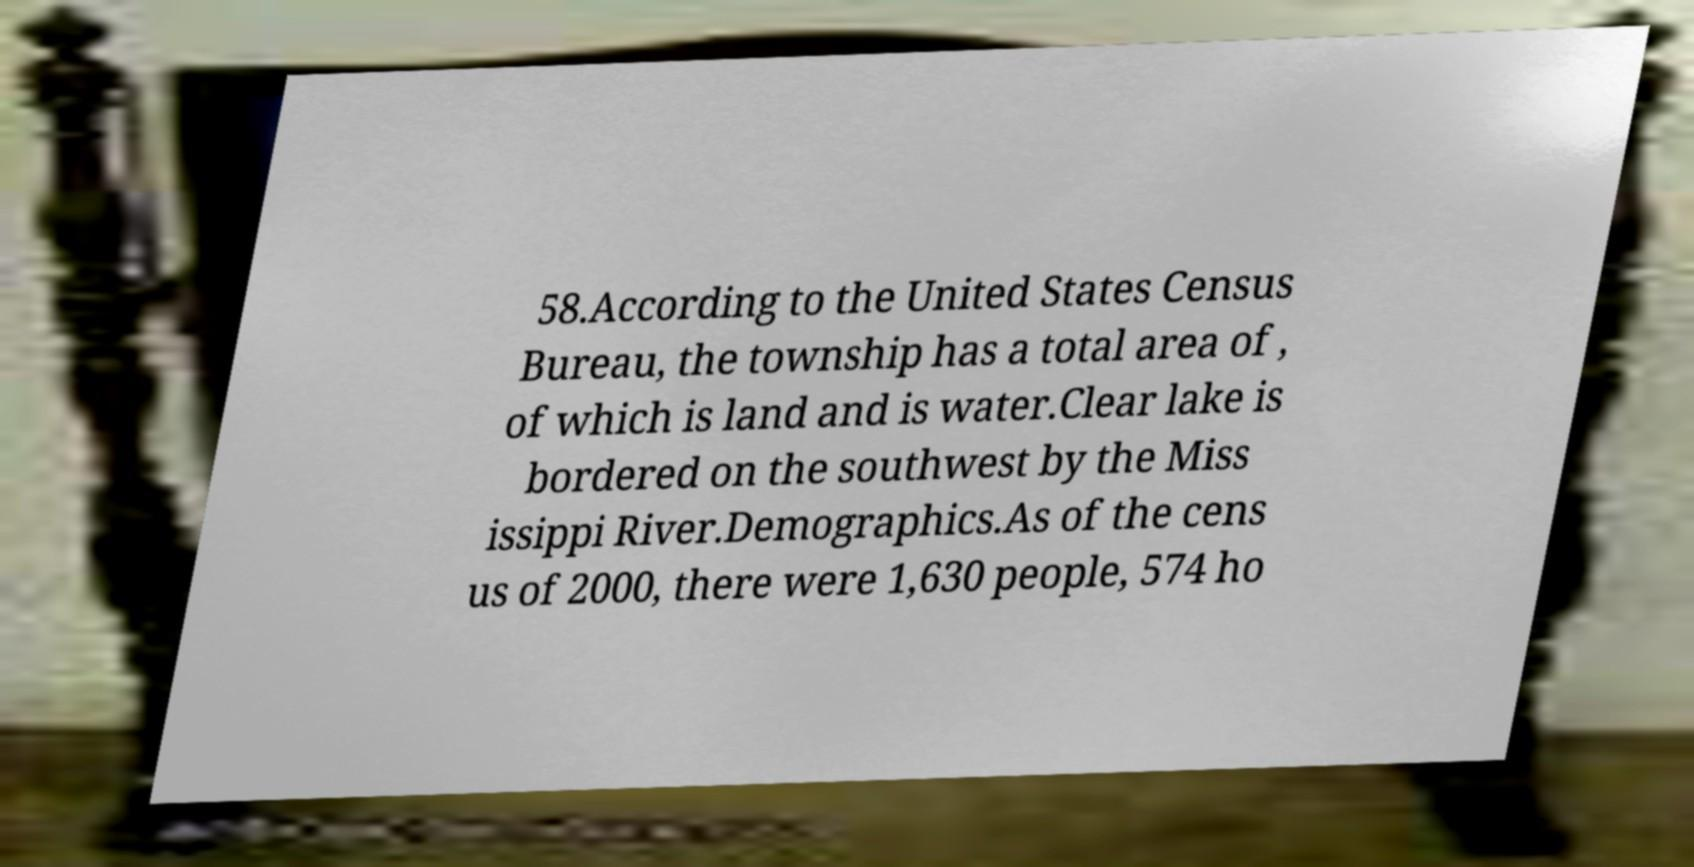Can you accurately transcribe the text from the provided image for me? 58.According to the United States Census Bureau, the township has a total area of , of which is land and is water.Clear lake is bordered on the southwest by the Miss issippi River.Demographics.As of the cens us of 2000, there were 1,630 people, 574 ho 